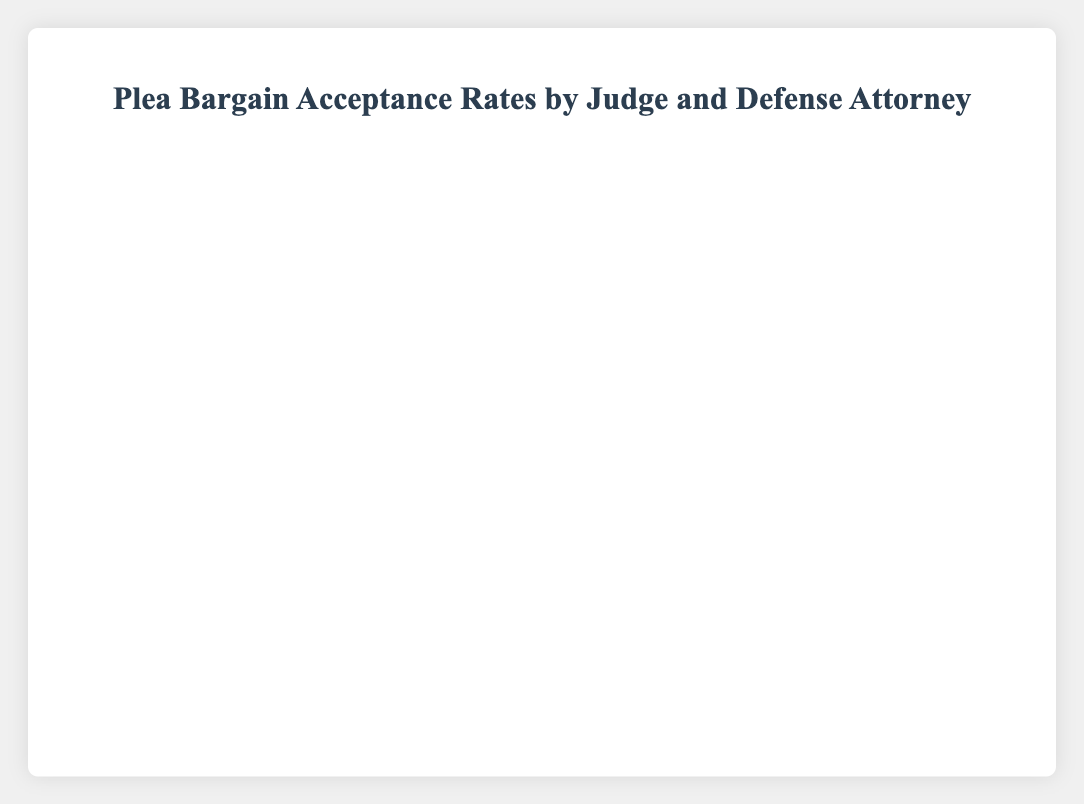Which judge had the highest number of plea bargains accepted by Attorney Wilson? By observing the heights of the bars representing "Accepted" cases by Attorney Wilson, we see that Judge Lee has the tallest bar indicating he accepted 50 cases.
Answer: Judge Lee What is the total number of plea bargains accepted and rejected by Judge Smith? Adding the accepted and rejected cases for all attorneys under Judge Smith: (35+15) + (25+20) + (30+10) = 115
Answer: 115 Compare the plea bargain acceptance rates between Attorney Brown and Attorney Davis under Judge Johnson. Which attorney had a higher acceptance rate? Attorney Brown had 40 cases accepted and 10 rejected, while Attorney Davis had 20 cases accepted and 25 rejected under Judge Johnson. Acceptance rates are calculated as Accepted / (Accepted + Rejected). For Attorney Brown: 40 / (40 + 10) = 0.80. For Attorney Davis: 20 / (20 + 25) = 0.44. Therefore, Attorney Brown had a higher acceptance rate.
Answer: Attorney Brown Which defense attorney had the highest combined number of accepted plea bargains across all judges? Summing the accepted cases across all judges for each attorney: 
Attorney Brown: 35 (Judge Smith) + 40 (Judge Johnson) + 45 (Judge Lee) = 120 
Attorney Davis: 25 (Judge Smith) + 20 (Judge Johnson) + 35 (Judge Lee) = 80 
Attorney Wilson: 30 (Judge Smith) + 30 (Judge Johnson) + 50 (Judge Lee) = 110. 
Attorney Brown thus had the highest combined number of accepted plea bargains.
Answer: Attorney Brown How many more plea bargains did Attorney Brown get accepted by Judge Lee compared to what Attorney Davis got accepted by Judge Smith? Attorney Brown had 45 accepted cases by Judge Lee, while Attorney Davis had 25 accepted cases by Judge Smith. Therefore, Brown got 45 - 25 = 20 more accepted.
Answer: 20 Compare the total number of accepted and rejected plea bargains handled by Attorney Wilson across all judges. Which is greater? Summing up the accepted and rejected cases for Attorney Wilson across all judges:
Accepted: 30 (Judge Smith) + 30 (Judge Johnson) + 50 (Judge Lee) = 110 
Rejected: 10 (Judge Smith) + 20 (Judge Johnson) + 10 (Judge Lee) = 40. 
The number of accepted cases is greater.
Answer: Accepted cases How does the number of plea bargains accepted by Attorney Davis under Judge Lee compare to those accepted by Judge Smith for the same attorney? Attorney Davis had 35 accepted cases under Judge Lee and 25 under Judge Smith, showing that Judge Lee accepted more plea bargains for Davis by a difference of 35 - 25 = 10 cases.
Answer: Judge Lee accepted more What percentage of plea bargains proposed by Attorney Brown were accepted by Judge Johnson? Attorney Brown had 40 accepted and 10 rejected under Judge Johnson. The percentage can be calculated as (Accepted / (Accepted + Rejected)) * 100. So, (40 / (40 + 10)) * 100 = 80%
Answer: 80% For Attorney Davis, how many plea bargains were rejected by Judge Smith compared to Judge Lee? Attorney Davis had 20 rejected cases under Judge Smith and 15 under Judge Lee, indicating Judge Smith rejected 5 more (20 - 15) cases than Judge Lee.
Answer: 5 Which judge had the lowest total number of plea bargains (both accepted and rejected) when considering all defense attorneys? Summing up accepted and rejected cases for each judge:
Judge Smith: (35+15) + (25+20) + (30+10) = 135
Judge Johnson: (40+10) + (20+25) + (30+20) = 145
Judge Lee: (45+20) + (35+15) + (50+10) = 195
Judge Smith, with 135 cases, had the lowest total number of plea bargains.
Answer: Judge Smith 